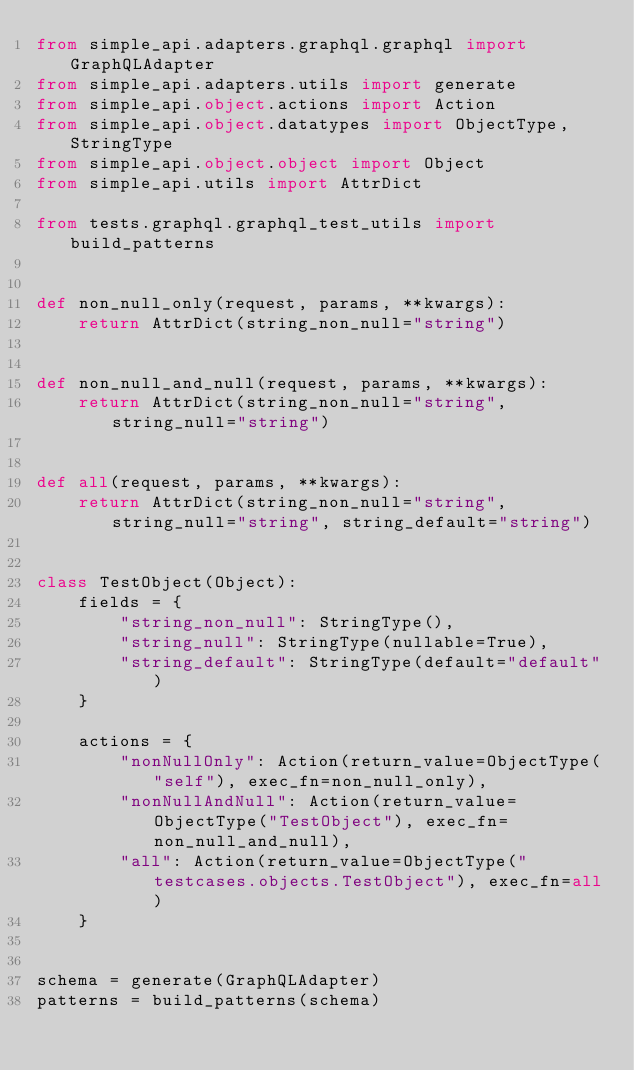<code> <loc_0><loc_0><loc_500><loc_500><_Python_>from simple_api.adapters.graphql.graphql import GraphQLAdapter
from simple_api.adapters.utils import generate
from simple_api.object.actions import Action
from simple_api.object.datatypes import ObjectType, StringType
from simple_api.object.object import Object
from simple_api.utils import AttrDict

from tests.graphql.graphql_test_utils import build_patterns


def non_null_only(request, params, **kwargs):
    return AttrDict(string_non_null="string")


def non_null_and_null(request, params, **kwargs):
    return AttrDict(string_non_null="string", string_null="string")


def all(request, params, **kwargs):
    return AttrDict(string_non_null="string", string_null="string", string_default="string")


class TestObject(Object):
    fields = {
        "string_non_null": StringType(),
        "string_null": StringType(nullable=True),
        "string_default": StringType(default="default")
    }

    actions = {
        "nonNullOnly": Action(return_value=ObjectType("self"), exec_fn=non_null_only),
        "nonNullAndNull": Action(return_value=ObjectType("TestObject"), exec_fn=non_null_and_null),
        "all": Action(return_value=ObjectType("testcases.objects.TestObject"), exec_fn=all)
    }


schema = generate(GraphQLAdapter)
patterns = build_patterns(schema)
</code> 